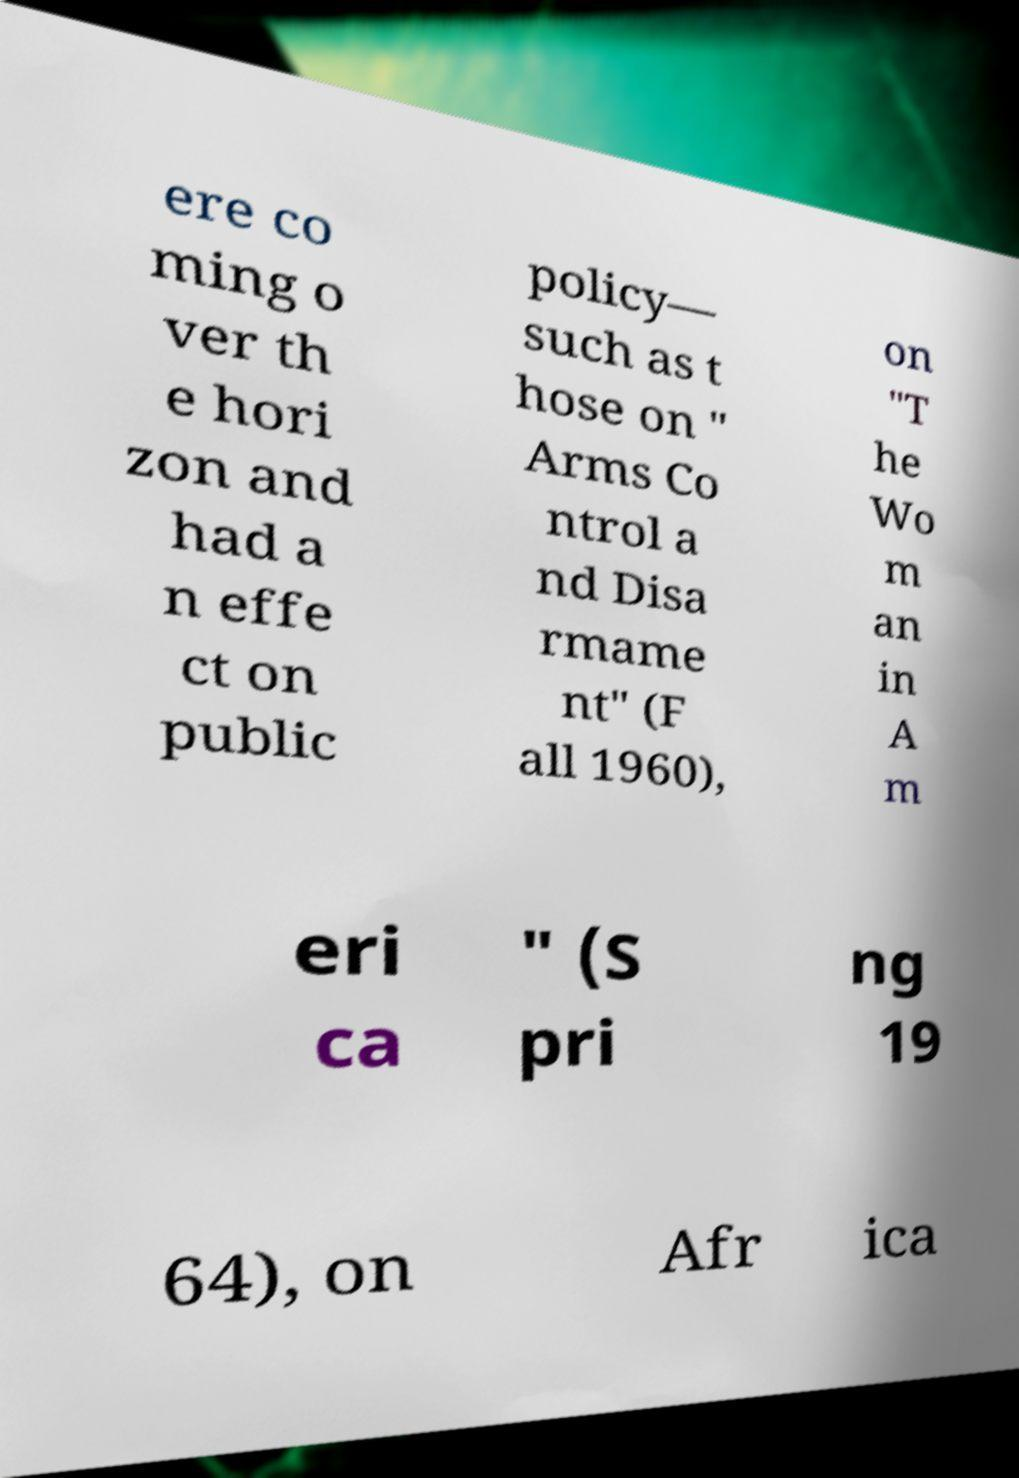Could you extract and type out the text from this image? ere co ming o ver th e hori zon and had a n effe ct on public policy— such as t hose on " Arms Co ntrol a nd Disa rmame nt" (F all 1960), on "T he Wo m an in A m eri ca " (S pri ng 19 64), on Afr ica 